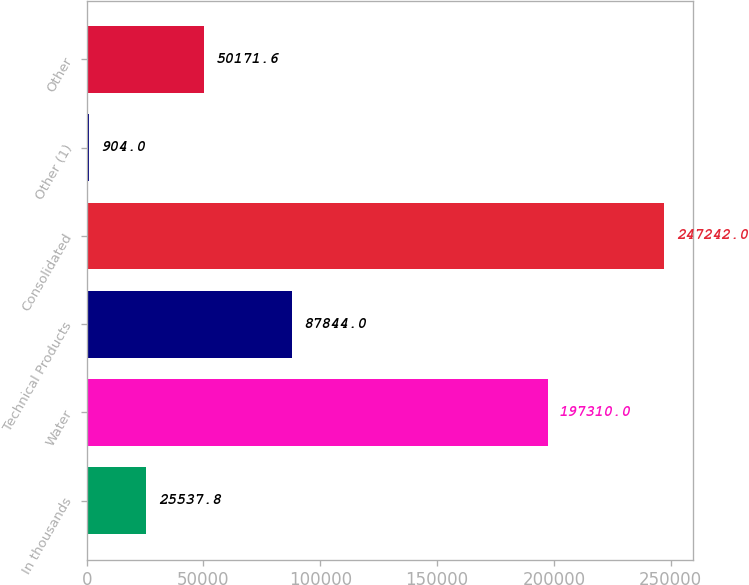Convert chart. <chart><loc_0><loc_0><loc_500><loc_500><bar_chart><fcel>In thousands<fcel>Water<fcel>Technical Products<fcel>Consolidated<fcel>Other (1)<fcel>Other<nl><fcel>25537.8<fcel>197310<fcel>87844<fcel>247242<fcel>904<fcel>50171.6<nl></chart> 